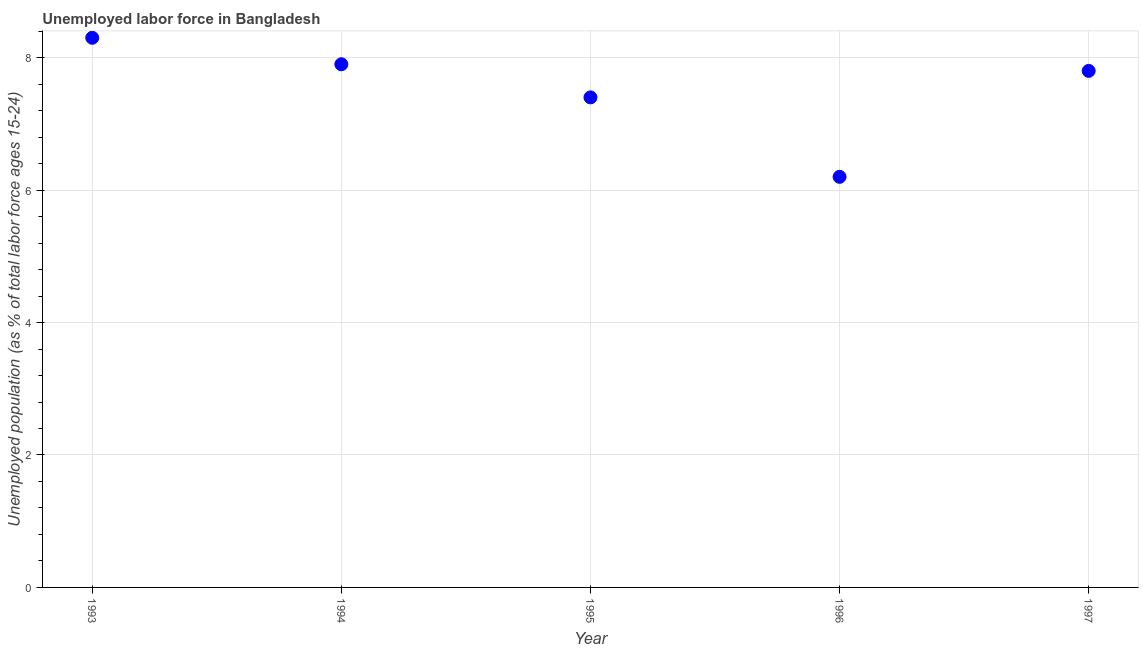What is the total unemployed youth population in 1995?
Offer a very short reply. 7.4. Across all years, what is the maximum total unemployed youth population?
Provide a succinct answer. 8.3. Across all years, what is the minimum total unemployed youth population?
Offer a very short reply. 6.2. In which year was the total unemployed youth population minimum?
Provide a succinct answer. 1996. What is the sum of the total unemployed youth population?
Offer a terse response. 37.6. What is the difference between the total unemployed youth population in 1993 and 1995?
Ensure brevity in your answer.  0.9. What is the average total unemployed youth population per year?
Keep it short and to the point. 7.52. What is the median total unemployed youth population?
Give a very brief answer. 7.8. In how many years, is the total unemployed youth population greater than 7.6 %?
Your response must be concise. 3. Do a majority of the years between 1997 and 1995 (inclusive) have total unemployed youth population greater than 0.4 %?
Your response must be concise. No. What is the ratio of the total unemployed youth population in 1994 to that in 1995?
Give a very brief answer. 1.07. What is the difference between the highest and the second highest total unemployed youth population?
Provide a succinct answer. 0.4. Is the sum of the total unemployed youth population in 1993 and 1997 greater than the maximum total unemployed youth population across all years?
Your answer should be very brief. Yes. What is the difference between the highest and the lowest total unemployed youth population?
Ensure brevity in your answer.  2.1. In how many years, is the total unemployed youth population greater than the average total unemployed youth population taken over all years?
Offer a terse response. 3. Does the total unemployed youth population monotonically increase over the years?
Provide a short and direct response. No. How many dotlines are there?
Keep it short and to the point. 1. Are the values on the major ticks of Y-axis written in scientific E-notation?
Ensure brevity in your answer.  No. Does the graph contain any zero values?
Offer a terse response. No. Does the graph contain grids?
Your response must be concise. Yes. What is the title of the graph?
Make the answer very short. Unemployed labor force in Bangladesh. What is the label or title of the Y-axis?
Offer a terse response. Unemployed population (as % of total labor force ages 15-24). What is the Unemployed population (as % of total labor force ages 15-24) in 1993?
Make the answer very short. 8.3. What is the Unemployed population (as % of total labor force ages 15-24) in 1994?
Keep it short and to the point. 7.9. What is the Unemployed population (as % of total labor force ages 15-24) in 1995?
Offer a terse response. 7.4. What is the Unemployed population (as % of total labor force ages 15-24) in 1996?
Offer a terse response. 6.2. What is the Unemployed population (as % of total labor force ages 15-24) in 1997?
Your response must be concise. 7.8. What is the difference between the Unemployed population (as % of total labor force ages 15-24) in 1993 and 1994?
Provide a succinct answer. 0.4. What is the difference between the Unemployed population (as % of total labor force ages 15-24) in 1993 and 1995?
Your answer should be compact. 0.9. What is the difference between the Unemployed population (as % of total labor force ages 15-24) in 1993 and 1996?
Provide a succinct answer. 2.1. What is the difference between the Unemployed population (as % of total labor force ages 15-24) in 1994 and 1995?
Ensure brevity in your answer.  0.5. What is the difference between the Unemployed population (as % of total labor force ages 15-24) in 1994 and 1996?
Your answer should be very brief. 1.7. What is the ratio of the Unemployed population (as % of total labor force ages 15-24) in 1993 to that in 1994?
Ensure brevity in your answer.  1.05. What is the ratio of the Unemployed population (as % of total labor force ages 15-24) in 1993 to that in 1995?
Give a very brief answer. 1.12. What is the ratio of the Unemployed population (as % of total labor force ages 15-24) in 1993 to that in 1996?
Offer a terse response. 1.34. What is the ratio of the Unemployed population (as % of total labor force ages 15-24) in 1993 to that in 1997?
Offer a very short reply. 1.06. What is the ratio of the Unemployed population (as % of total labor force ages 15-24) in 1994 to that in 1995?
Offer a very short reply. 1.07. What is the ratio of the Unemployed population (as % of total labor force ages 15-24) in 1994 to that in 1996?
Give a very brief answer. 1.27. What is the ratio of the Unemployed population (as % of total labor force ages 15-24) in 1995 to that in 1996?
Give a very brief answer. 1.19. What is the ratio of the Unemployed population (as % of total labor force ages 15-24) in 1995 to that in 1997?
Provide a short and direct response. 0.95. What is the ratio of the Unemployed population (as % of total labor force ages 15-24) in 1996 to that in 1997?
Your answer should be compact. 0.8. 